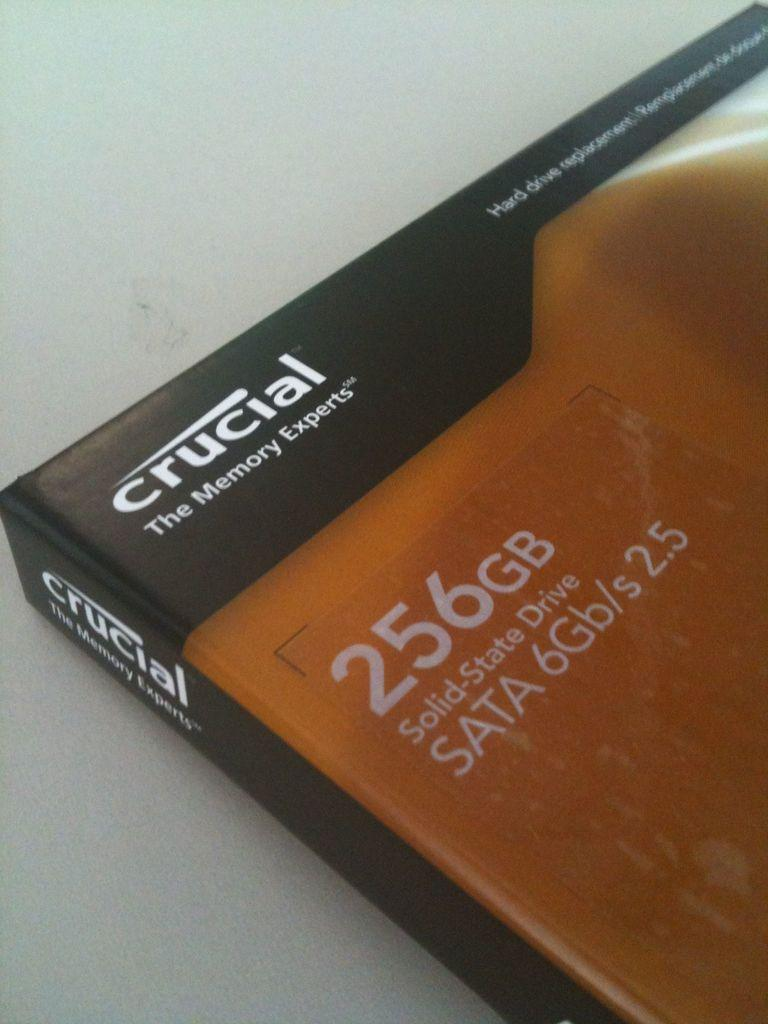Provide a one-sentence caption for the provided image. a crucial The Memory Experts Solid State Drive. 